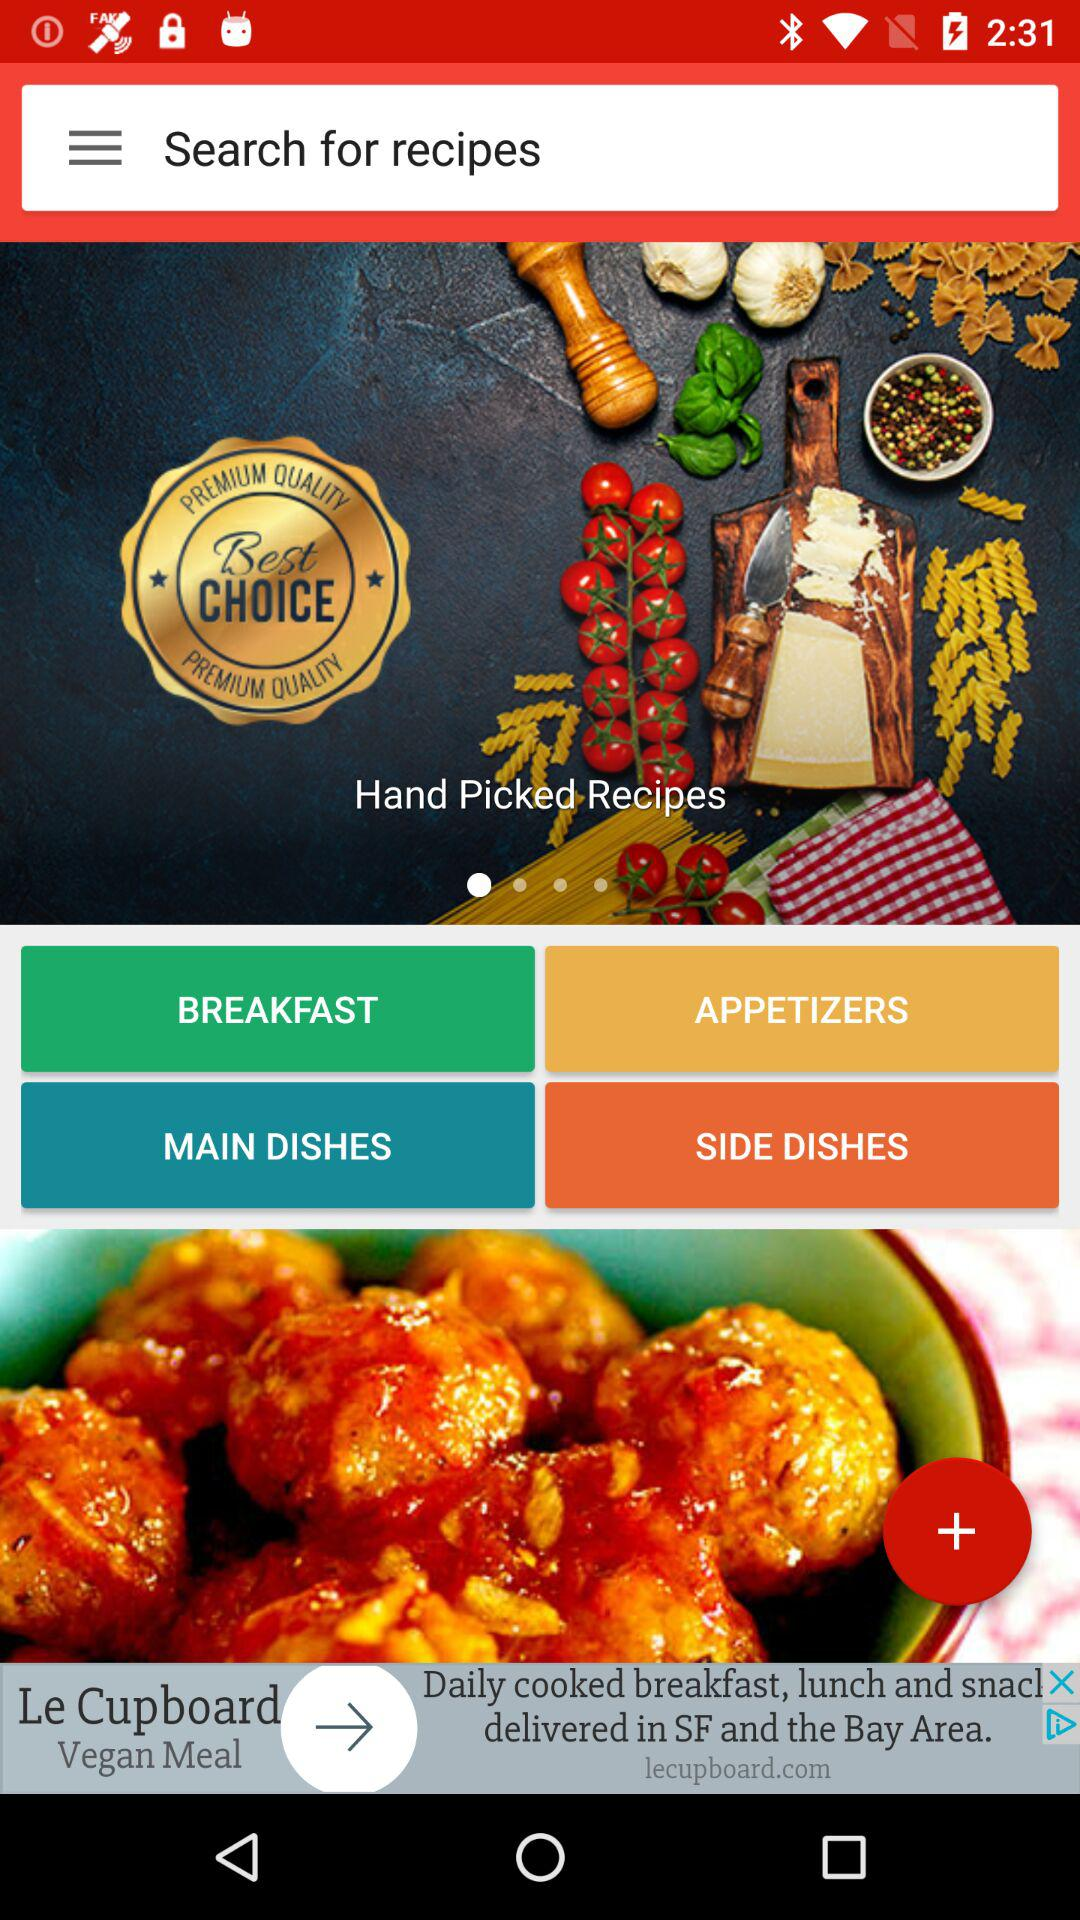What's the type of recipe? The type of recipe is "Hand Picked". 